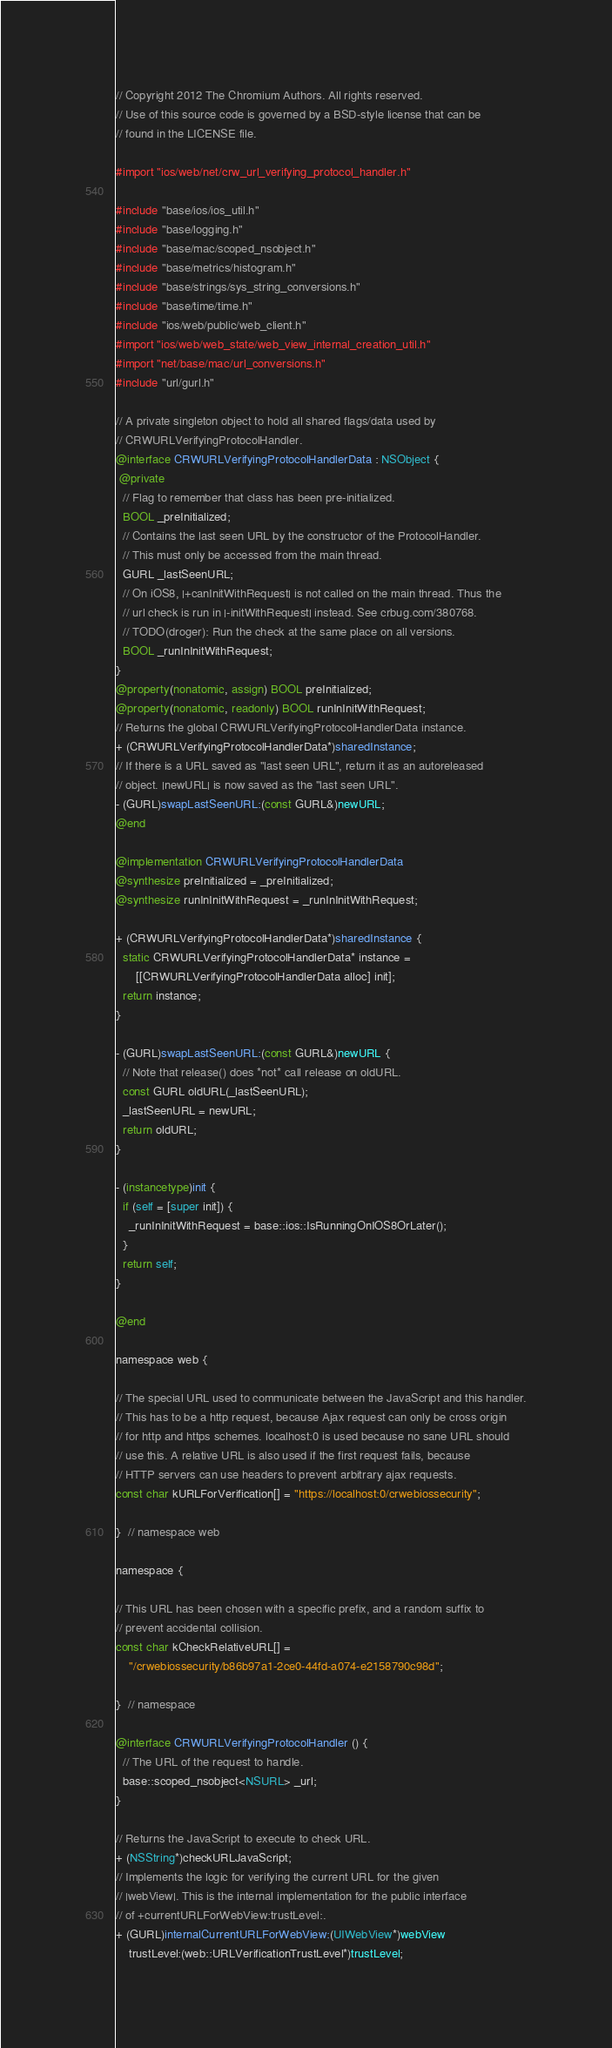Convert code to text. <code><loc_0><loc_0><loc_500><loc_500><_ObjectiveC_>// Copyright 2012 The Chromium Authors. All rights reserved.
// Use of this source code is governed by a BSD-style license that can be
// found in the LICENSE file.

#import "ios/web/net/crw_url_verifying_protocol_handler.h"

#include "base/ios/ios_util.h"
#include "base/logging.h"
#include "base/mac/scoped_nsobject.h"
#include "base/metrics/histogram.h"
#include "base/strings/sys_string_conversions.h"
#include "base/time/time.h"
#include "ios/web/public/web_client.h"
#import "ios/web/web_state/web_view_internal_creation_util.h"
#import "net/base/mac/url_conversions.h"
#include "url/gurl.h"

// A private singleton object to hold all shared flags/data used by
// CRWURLVerifyingProtocolHandler.
@interface CRWURLVerifyingProtocolHandlerData : NSObject {
 @private
  // Flag to remember that class has been pre-initialized.
  BOOL _preInitialized;
  // Contains the last seen URL by the constructor of the ProtocolHandler.
  // This must only be accessed from the main thread.
  GURL _lastSeenURL;
  // On iOS8, |+canInitWithRequest| is not called on the main thread. Thus the
  // url check is run in |-initWithRequest| instead. See crbug.com/380768.
  // TODO(droger): Run the check at the same place on all versions.
  BOOL _runInInitWithRequest;
}
@property(nonatomic, assign) BOOL preInitialized;
@property(nonatomic, readonly) BOOL runInInitWithRequest;
// Returns the global CRWURLVerifyingProtocolHandlerData instance.
+ (CRWURLVerifyingProtocolHandlerData*)sharedInstance;
// If there is a URL saved as "last seen URL", return it as an autoreleased
// object. |newURL| is now saved as the "last seen URL".
- (GURL)swapLastSeenURL:(const GURL&)newURL;
@end

@implementation CRWURLVerifyingProtocolHandlerData
@synthesize preInitialized = _preInitialized;
@synthesize runInInitWithRequest = _runInInitWithRequest;

+ (CRWURLVerifyingProtocolHandlerData*)sharedInstance {
  static CRWURLVerifyingProtocolHandlerData* instance =
      [[CRWURLVerifyingProtocolHandlerData alloc] init];
  return instance;
}

- (GURL)swapLastSeenURL:(const GURL&)newURL {
  // Note that release() does *not* call release on oldURL.
  const GURL oldURL(_lastSeenURL);
  _lastSeenURL = newURL;
  return oldURL;
}

- (instancetype)init {
  if (self = [super init]) {
    _runInInitWithRequest = base::ios::IsRunningOnIOS8OrLater();
  }
  return self;
}

@end

namespace web {

// The special URL used to communicate between the JavaScript and this handler.
// This has to be a http request, because Ajax request can only be cross origin
// for http and https schemes. localhost:0 is used because no sane URL should
// use this. A relative URL is also used if the first request fails, because
// HTTP servers can use headers to prevent arbitrary ajax requests.
const char kURLForVerification[] = "https://localhost:0/crwebiossecurity";

}  // namespace web

namespace {

// This URL has been chosen with a specific prefix, and a random suffix to
// prevent accidental collision.
const char kCheckRelativeURL[] =
    "/crwebiossecurity/b86b97a1-2ce0-44fd-a074-e2158790c98d";

}  // namespace

@interface CRWURLVerifyingProtocolHandler () {
  // The URL of the request to handle.
  base::scoped_nsobject<NSURL> _url;
}

// Returns the JavaScript to execute to check URL.
+ (NSString*)checkURLJavaScript;
// Implements the logic for verifying the current URL for the given
// |webView|. This is the internal implementation for the public interface
// of +currentURLForWebView:trustLevel:.
+ (GURL)internalCurrentURLForWebView:(UIWebView*)webView
    trustLevel:(web::URLVerificationTrustLevel*)trustLevel;</code> 